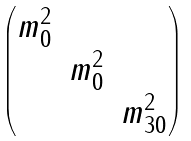Convert formula to latex. <formula><loc_0><loc_0><loc_500><loc_500>\begin{pmatrix} m _ { 0 } ^ { 2 } & & \\ & m _ { 0 } ^ { 2 } & \\ & & m _ { 3 0 } ^ { 2 } \end{pmatrix}</formula> 